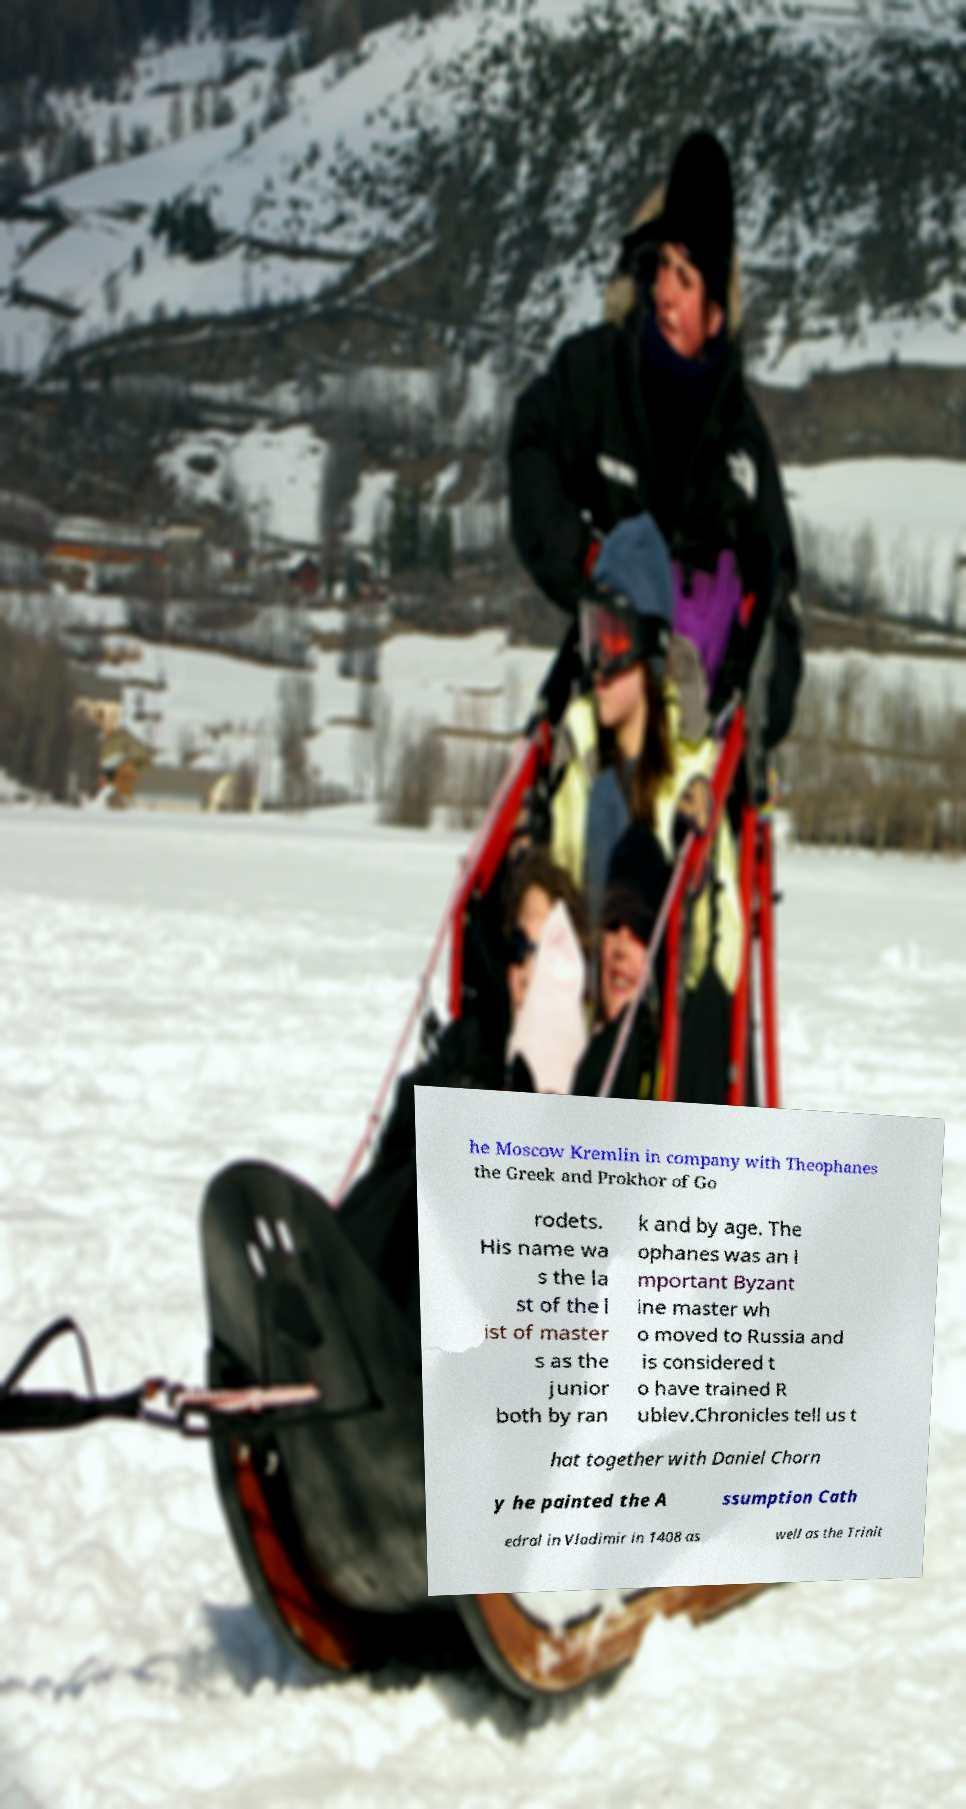Please identify and transcribe the text found in this image. he Moscow Kremlin in company with Theophanes the Greek and Prokhor of Go rodets. His name wa s the la st of the l ist of master s as the junior both by ran k and by age. The ophanes was an i mportant Byzant ine master wh o moved to Russia and is considered t o have trained R ublev.Chronicles tell us t hat together with Daniel Chorn y he painted the A ssumption Cath edral in Vladimir in 1408 as well as the Trinit 